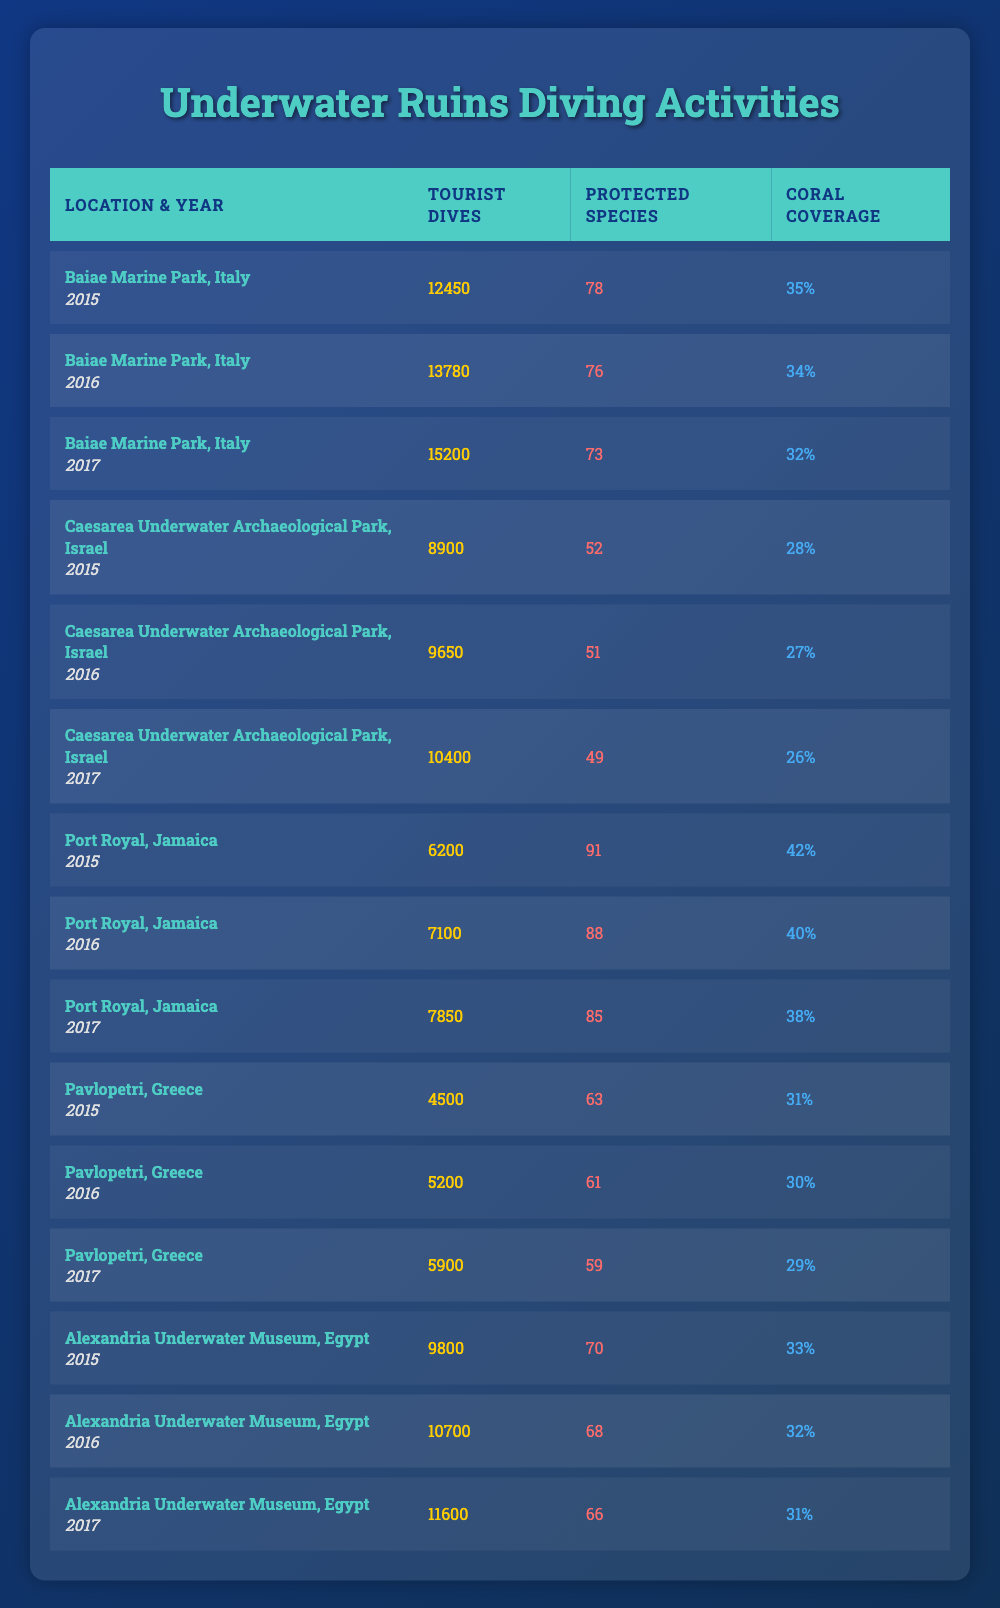What was the total number of tourist dives in 2017 across all locations? In 2017, the tourist dives were 15200 (Baiae), 10400 (Caesarea), 7850 (Port Royal), 5900 (Pavlopetri), and 11600 (Alexandria). Adding these together gives 15200 + 10400 + 7850 + 5900 + 11600 = 55050.
Answer: 55050 Which location had the highest tourist dives in 2016? In 2016, the tourist dives for each location were 13780 (Baiae), 9650 (Caesarea), 7100 (Port Royal), 5200 (Pavlopetri), and 10700 (Alexandria). The maximum is 13780 at Baiae Marine Park.
Answer: Baiae Marine Park Did coral coverage increase in the Baiae Marine Park from 2015 to 2017? In 2015, coral coverage was 35%, and in 2017 it was 32%. This indicates a decrease over the years.
Answer: No What is the average number of tourist dives at the Pavlopetri location from 2015 to 2017? In 2015, the dives were 4500, in 2016 they were 5200, and in 2017 they were 5900. The total is 4500 + 5200 + 5900 = 15600, and the average over 3 years is 15600 / 3 = 5200.
Answer: 5200 Which year had the lowest tourist dives in Port Royal? The tourist dives for Port Royal were 6200 in 2015, 7100 in 2016, and 7850 in 2017. The lowest was 6200 in 2015.
Answer: 2015 Is it true that the number of protected species at the Caesarea Underwater Archaeological Park decreased from 2015 to 2017? In 2015, there were 52 species, in 2016 it was 51, and in 2017 it was 49. Each year saw a decrease.
Answer: Yes What was the percentage decrease in coral coverage at Port Royal from 2015 to 2017? Coral coverage in 2015 was 42% and in 2017 it was 38%. The decrease is 42% - 38% = 4%. To find the percentage decrease, (4% / 42%) * 100 = approximately 9.52%.
Answer: Approximately 9.52% Which location had the highest average protected species count across all years? The average protected species counts are as follows: Baiae (75.67), Caesarea (50.67), Port Royal (88), Pavlopetri (61), and Alexandria (68). The highest average is 88 at Port Royal.
Answer: Port Royal In which year did Alexandria Underwater Museum have the highest tourist dives? The tourist dives for Alexandria were 9800 in 2015, 10700 in 2016, and 11600 in 2017. The highest count was in 2017 with 11600 dives.
Answer: 2017 What is the total number of protected species across all locations in the year 2016? In 2016, protected species counts were 78 (Baiae), 51 (Caesarea), 88 (Port Royal), 61 (Pavlopetri), and 68 (Alexandria). The total is 78 + 51 + 88 + 61 + 68 = 346.
Answer: 346 How much did the total number of tourist dives change from 2015 to 2017 at Baiae Marine Park? In 2015, there were 12450 dives and in 2017, there were 15200 dives. The change is 15200 - 12450 = 2750 dives more in 2017.
Answer: 2750 more 